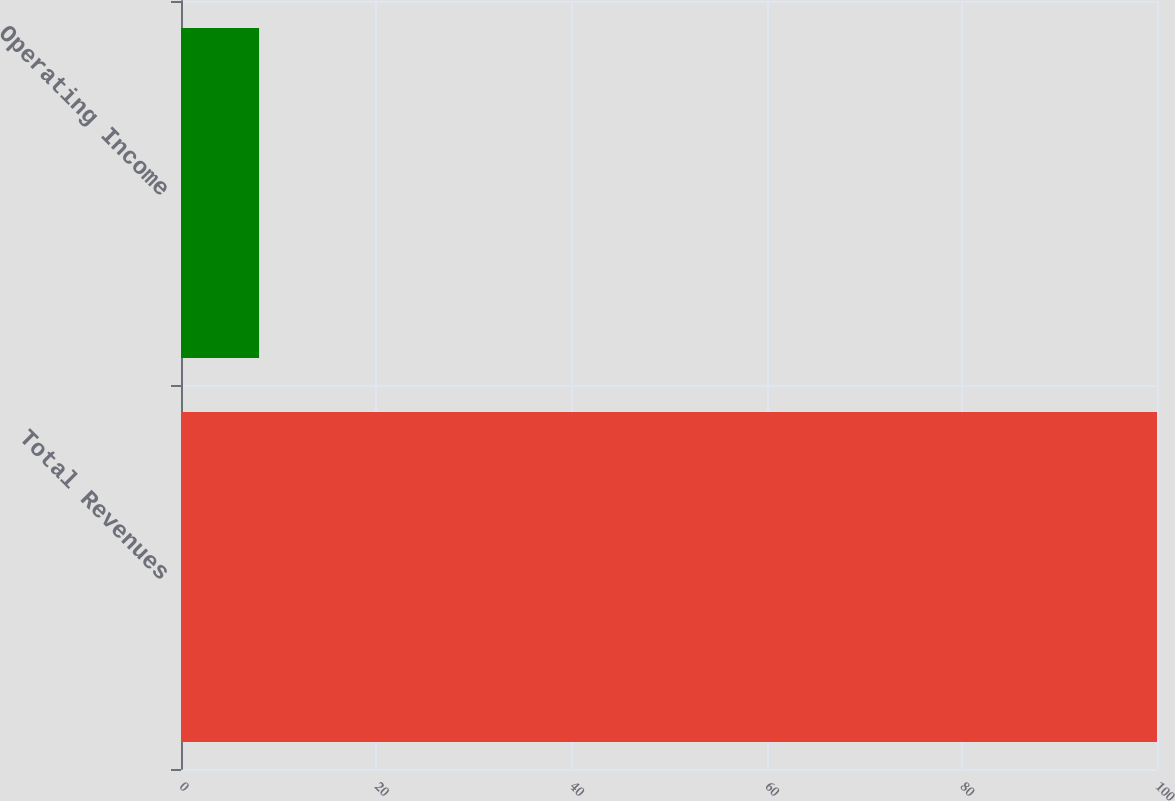<chart> <loc_0><loc_0><loc_500><loc_500><bar_chart><fcel>Total Revenues<fcel>Operating Income<nl><fcel>100<fcel>8<nl></chart> 